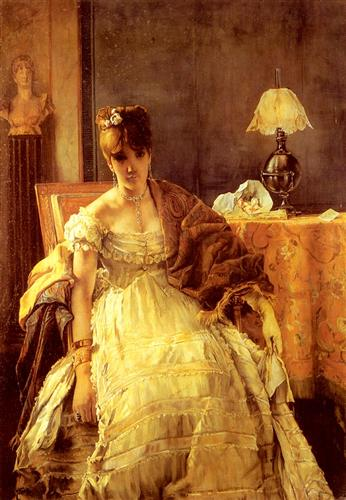If this painting depicted a scene from a novel, what kind of story would it tell? In a richly-hued novel, this painting would be a pivotal scene from a tale of love, loss, and rediscovery. The woman, Lady Evelyn, would be a character caught in the throes of a societal shift, her life transformed by a series of unforeseen events. An heiress to a great fortune, she navigates the complexities of her roles and expectations, while yearning for personal freedom and expression. The novel would delve into her intricate relationships, the forbidden love affair with a common but intellectually stimulating artist, and the ensuing scandal that forces her into social exile. As she sits in quiet contemplation, this painting captures a moment of deep introspection where she decides to reclaim her life, break free from societal constraints, and pursue her own path in the changing world around her. Concertizing in today's popular culture, what would be the modern equivalent of this painting? A modern equivalent of this painting might depict a successful woman in a chic, contemporary setting. Instead of an elegant gown and a plush sofa, she might be adorned in a stylish business suit or a fashionable dress, possibly working in a sleek, minimalist office. Instead of a traditional lamp on the table, there might be the soft glow of a modern desk lamp and a laptop instead of a vase. The backdrop would maintain the refined, muted tones but with modern art hanging on the walls. This updated scene would still capture a moment of contemplation and introspection but within the context of today's rapidly evolving, dynamic world. 